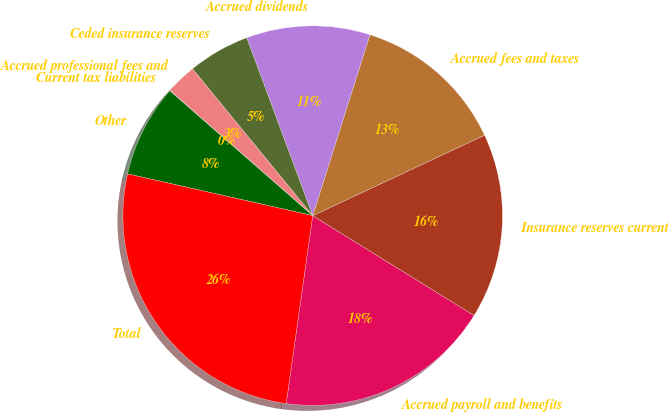Convert chart. <chart><loc_0><loc_0><loc_500><loc_500><pie_chart><fcel>Accrued payroll and benefits<fcel>Insurance reserves current<fcel>Accrued fees and taxes<fcel>Accrued dividends<fcel>Ceded insurance reserves<fcel>Accrued professional fees and<fcel>Current tax liabilities<fcel>Other<fcel>Total<nl><fcel>18.42%<fcel>15.79%<fcel>13.16%<fcel>10.53%<fcel>5.27%<fcel>2.64%<fcel>0.01%<fcel>7.9%<fcel>26.31%<nl></chart> 